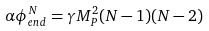Convert formula to latex. <formula><loc_0><loc_0><loc_500><loc_500>\alpha \phi _ { e n d } ^ { N } = \gamma M _ { P } ^ { 2 } ( N - 1 ) ( N - 2 )</formula> 